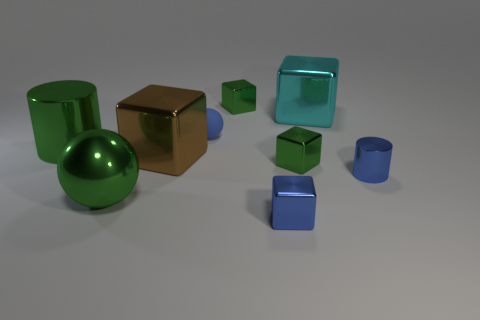Are there any shiny things of the same color as the rubber thing?
Ensure brevity in your answer.  Yes. How many things are either small green things that are behind the large cyan thing or small objects in front of the large green metal cylinder?
Provide a short and direct response. 4. Is there a green thing to the right of the big shiny cube that is in front of the tiny rubber ball?
Provide a short and direct response. Yes. The brown metal thing that is the same size as the green shiny sphere is what shape?
Your answer should be compact. Cube. How many things are either small cubes that are behind the large brown metal block or small yellow rubber cylinders?
Your answer should be compact. 1. What number of other things are there of the same material as the large cyan block
Offer a terse response. 7. What shape is the large metal thing that is the same color as the large metallic ball?
Your answer should be compact. Cylinder. There is a object that is behind the cyan metallic block; how big is it?
Make the answer very short. Small. There is a brown thing that is the same material as the blue block; what shape is it?
Your response must be concise. Cube. Is the material of the tiny blue sphere the same as the small thing in front of the small blue metallic cylinder?
Your response must be concise. No. 